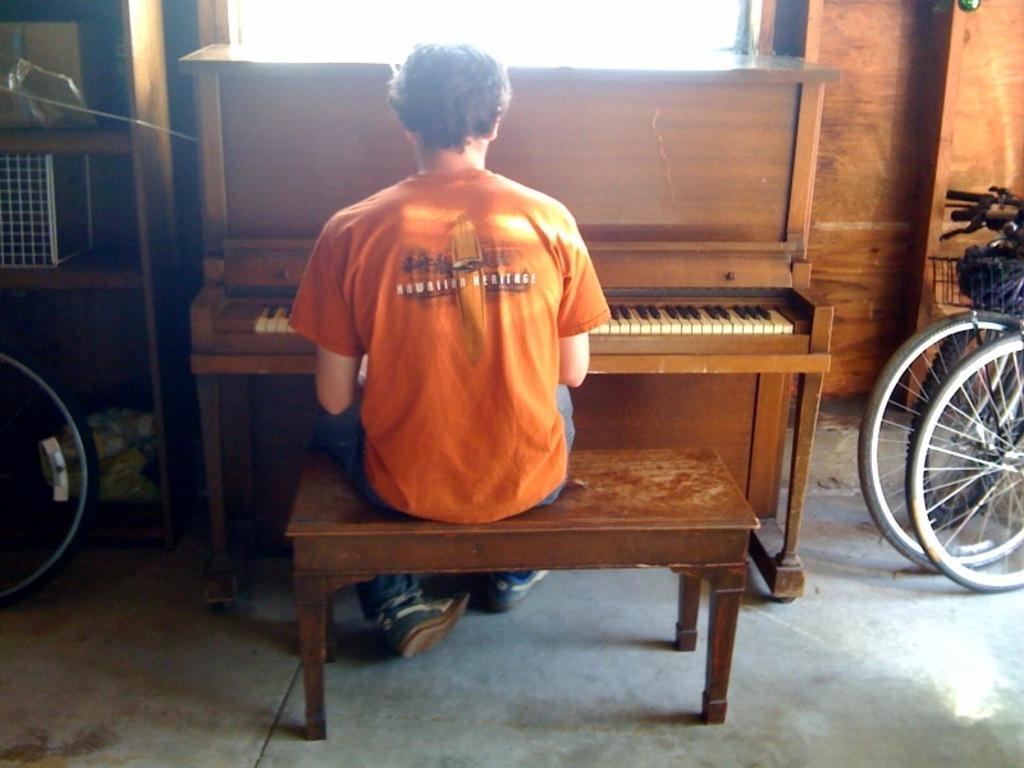How would you summarize this image in a sentence or two? In the middle of the image a man is sitting on a chair and playing piano. Behind him there is a wall. Bottom right side of the image there is a bicycle. Bottom left side of the image there is a bicycle. 